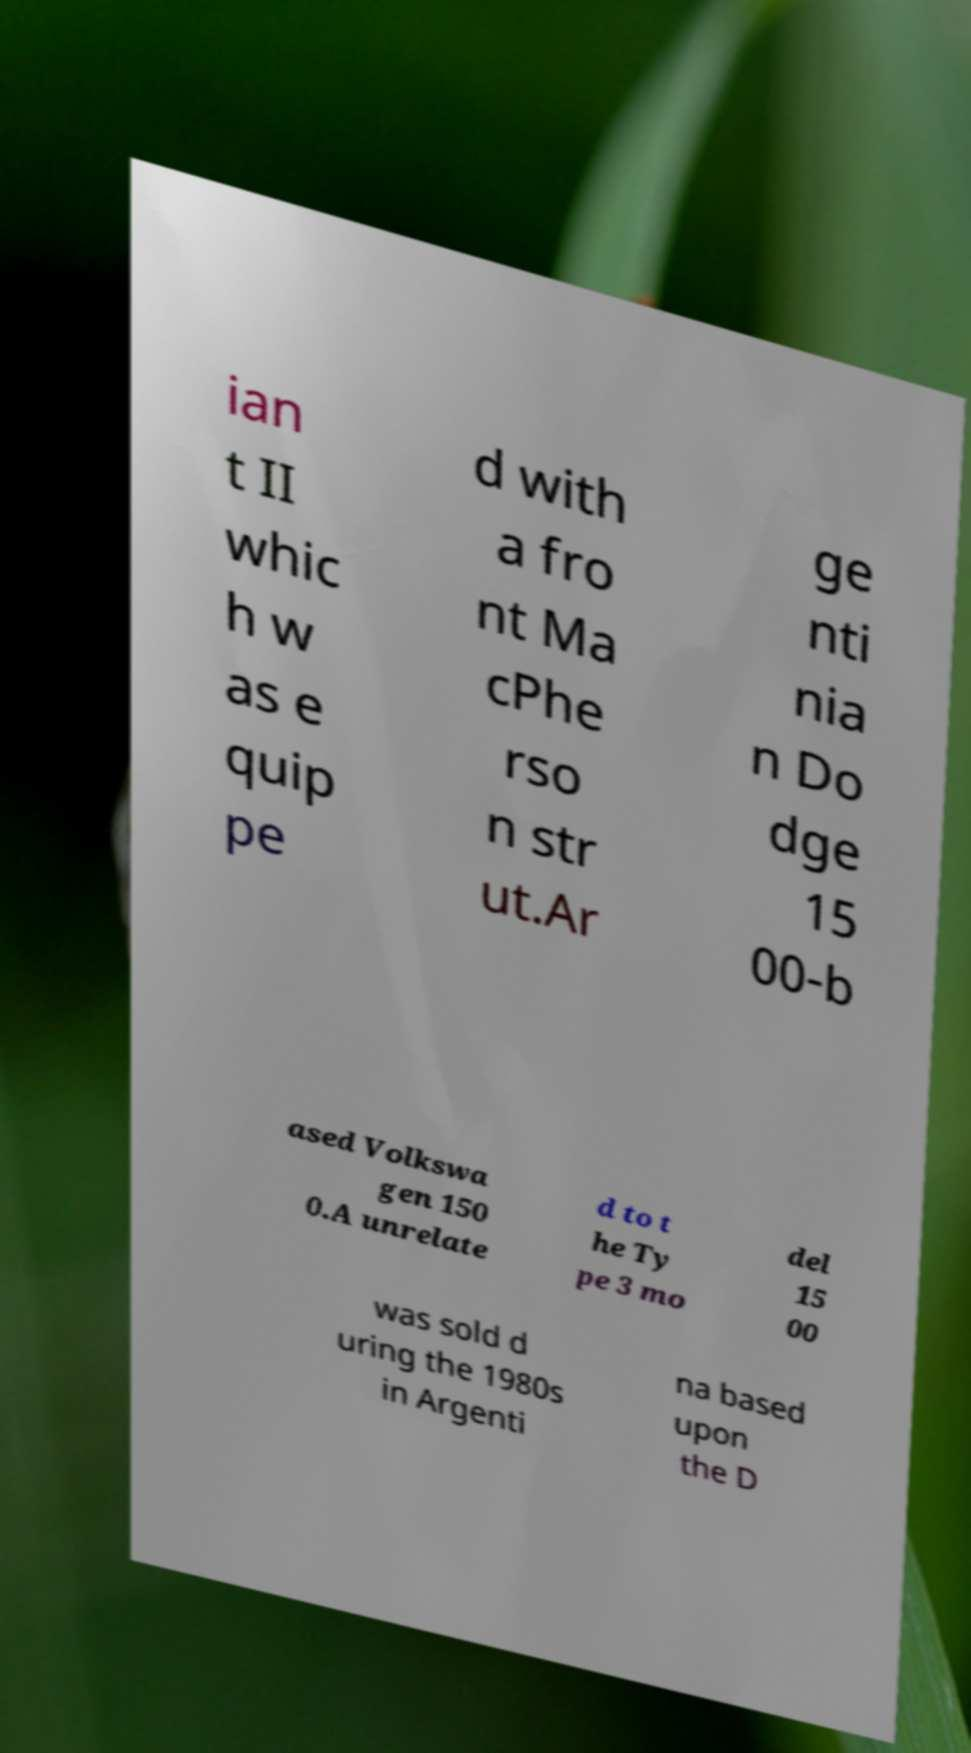I need the written content from this picture converted into text. Can you do that? ian t II whic h w as e quip pe d with a fro nt Ma cPhe rso n str ut.Ar ge nti nia n Do dge 15 00-b ased Volkswa gen 150 0.A unrelate d to t he Ty pe 3 mo del 15 00 was sold d uring the 1980s in Argenti na based upon the D 